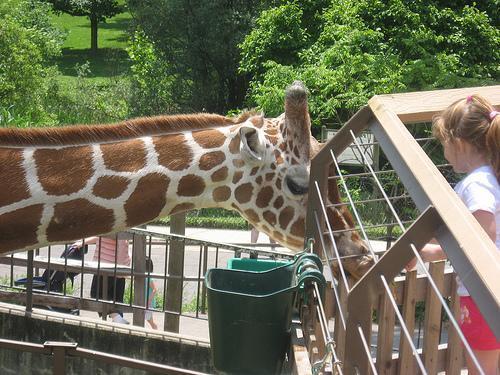How many people are feeding the giraffe?
Give a very brief answer. 1. 